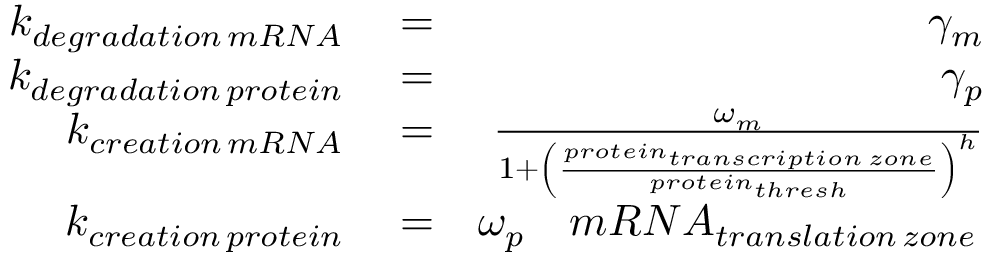Convert formula to latex. <formula><loc_0><loc_0><loc_500><loc_500>\begin{array} { r l r } { k _ { d e g r a d a t i o n \, m R N A } } & = } & { \gamma _ { m } } \\ { k _ { d e g r a d a t i o n \, p r o t e i n } } & = } & { \gamma _ { p } } \\ { k _ { c r e a t i o n \, m R N A } } & = } & { \frac { \omega _ { m } } { 1 + \left ( \frac { p r o t e i n _ { t r a n s c r i p t i o n \, z o n e } } { p r o t e i n _ { t h r e s h } } \right ) ^ { h } } } \\ { k _ { c r e a t i o n \, p r o t e i n } } & = } & { \omega _ { p } \quad m R N A _ { t r a n s l a t i o n \, z o n e } \, } \end{array}</formula> 